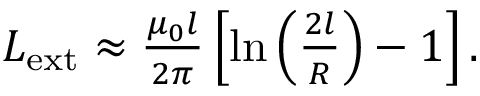Convert formula to latex. <formula><loc_0><loc_0><loc_500><loc_500>\begin{array} { r } { L _ { e x t } \approx \frac { \mu _ { 0 } l } { 2 \pi } \left [ \ln \left ( \frac { 2 l } { R } \right ) - 1 \right ] . } \end{array}</formula> 